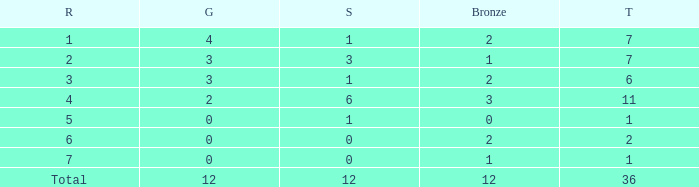What is the highest number of silver medals for a team with total less than 1? None. 